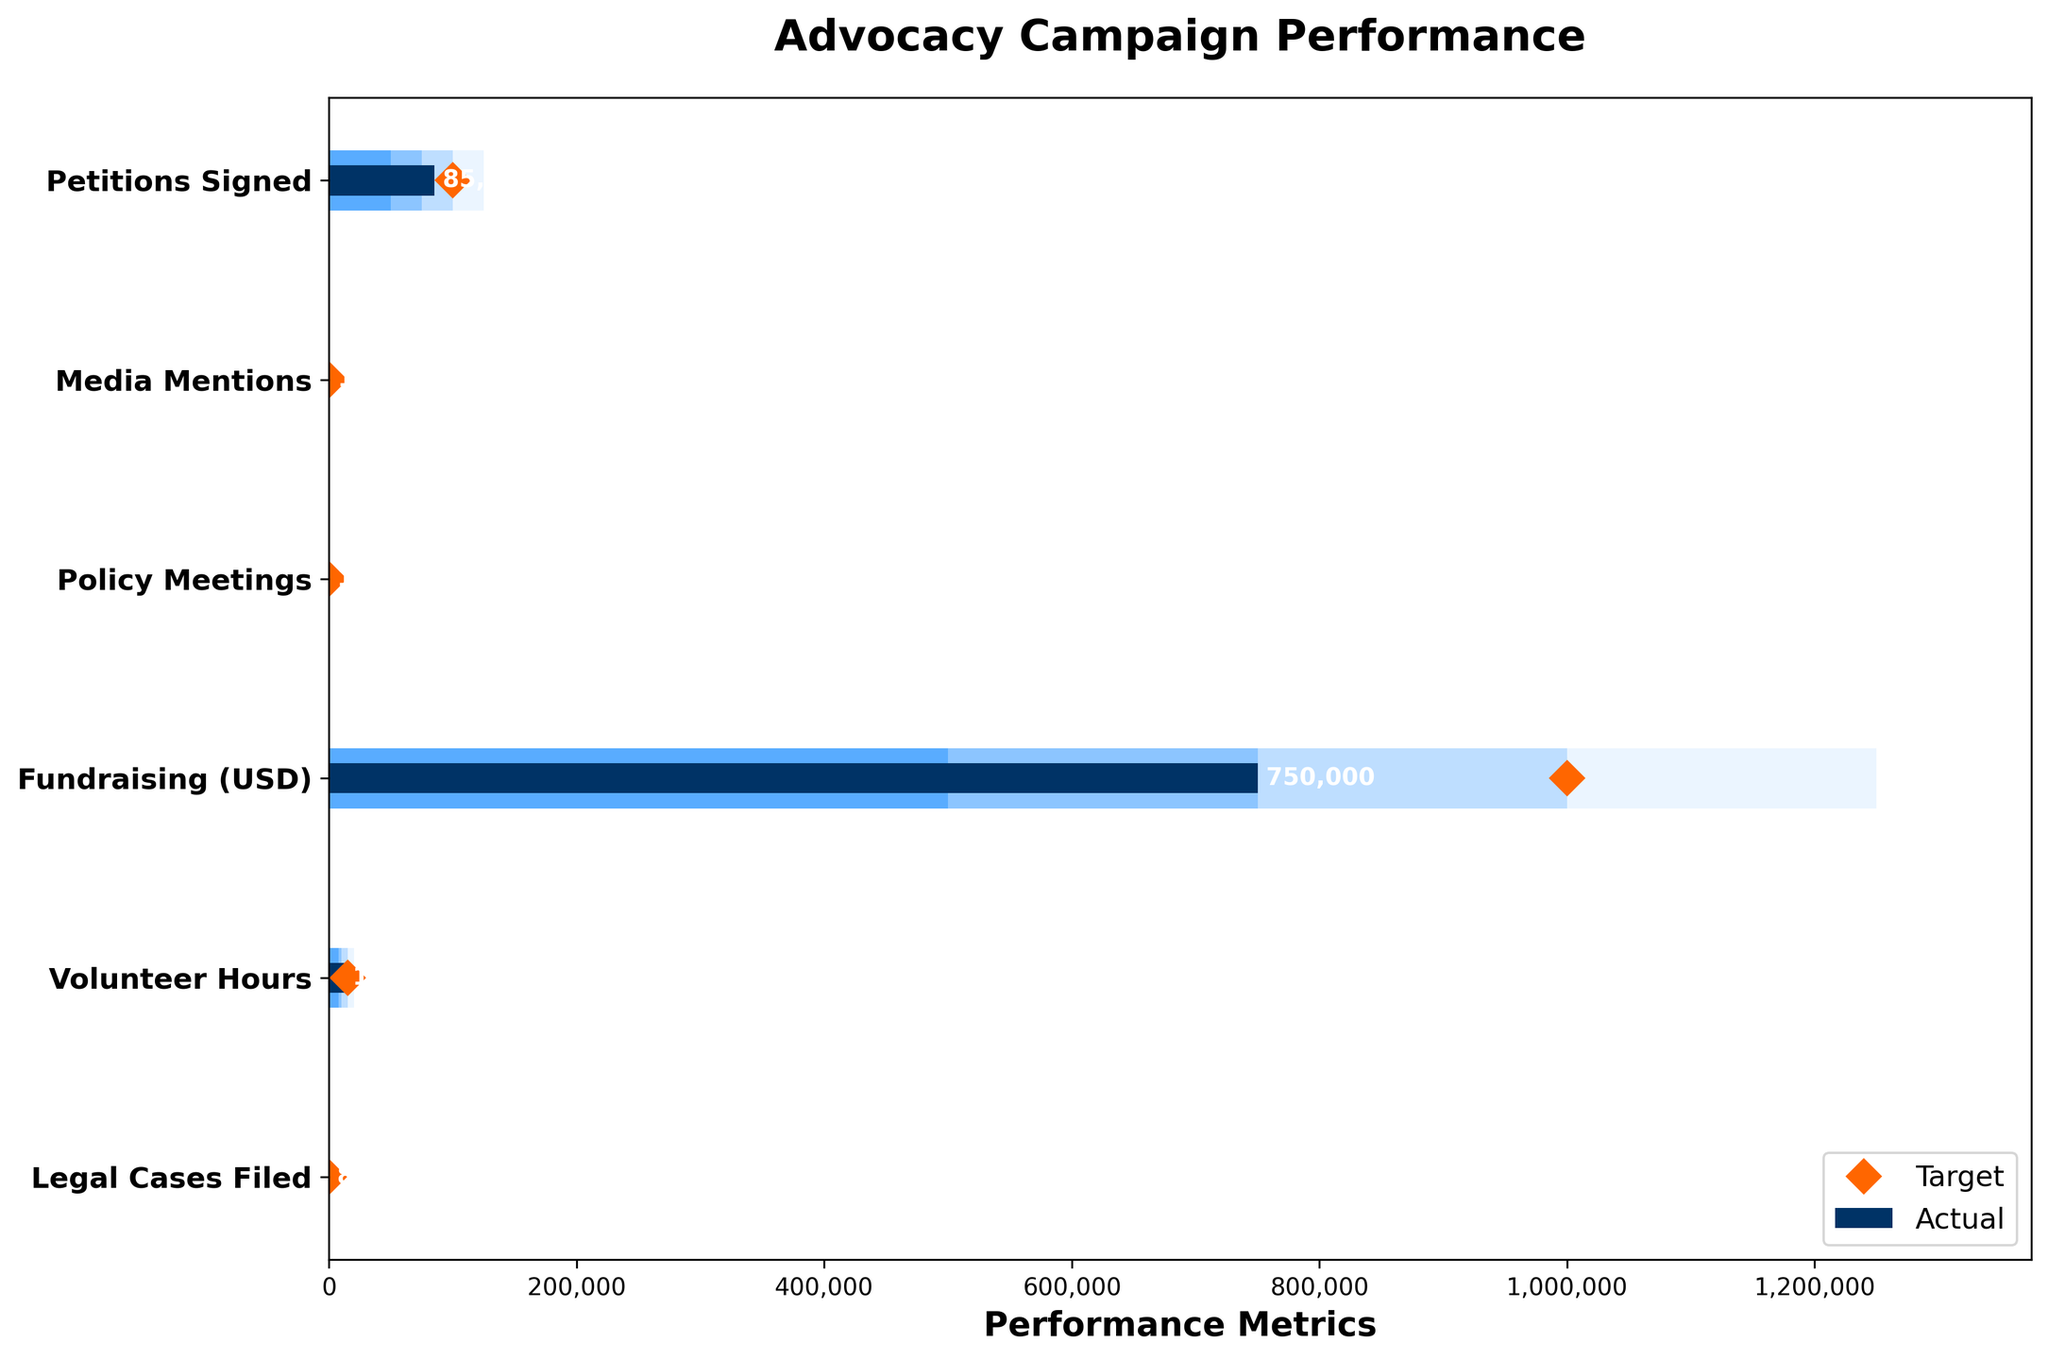What's the title of the chart? The title of the chart is positioned at the top center. It reads "Advocacy Campaign Performance".
Answer: Advocacy Campaign Performance What is the actual number of petitions signed? The bar corresponding to 'Petitions Signed' shows the value at the end of the dark blue section, which has a label indicating the actual metric.
Answer: 85,000 How many volunteer hours did we achieve compared to our target? The 'Volunteer Hours' category shows a dark blue bar labeled 'Actual' at 12,500 and an orange diamond marker for 'Target' at 15,000.
Answer: 12,500 vs. 15,000 Which performance metric has the smallest difference between the actual and target values? By comparing the distances between the end of the 'Actual' bars and the 'Target' diamond markers, 'Media Mentions' has the smallest difference (120 vs. 150).
Answer: Media Mentions How many more policy meetings are needed to meet the target? The actual number of policy meetings is 18, and the target is 25. Subtract the actual from the target (25 - 18).
Answer: 7 In which categories have we not yet reached the 'Good' threshold? The 'Good' thresholds are 100,000 for Petitions Signed, 150 for Media Mentions, 25 for Policy Meetings, 1,000,000 for Fundraising (USD), 15,000 for Volunteer Hours, and 10 for Legal Cases Filed. Check the actual values against these.
Answer: Petitions Signed, Policy Meetings, Fundraising, Volunteer Hours, Legal Cases Filed Which category has exceeded the 'Excellent' benchmark, if any? Compare the actual values with the 'Excellent' benchmarks. None of the categories' actual values surpasses the 'Excellent' benchmarks.
Answer: None Are there any categories where the actual performance matches exactly with the 'Poor' threshold? The 'Poor' thresholds are the smallest benchmarks for each category. The actual values for all categories exceed these poorest levels.
Answer: No What is the range of the 'Satisfactory' benchmark for Media Mentions? The 'Satisfactory' benchmark for Media Mentions spans from 100 to 150 as shown by the lighter blue bar section.
Answer: 100 to 150 By how much did Fundraising fall short of its target? The actual fundraising amount is 750,000 USD and the target is 1,000,000 USD. The difference is (1,000,000 - 750,000).
Answer: 250,000 USD 